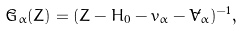Convert formula to latex. <formula><loc_0><loc_0><loc_500><loc_500>\tilde { G } _ { \alpha } ( Z ) = ( Z - H _ { 0 } - v _ { \alpha } - \tilde { V } _ { \alpha } ) ^ { - 1 } ,</formula> 